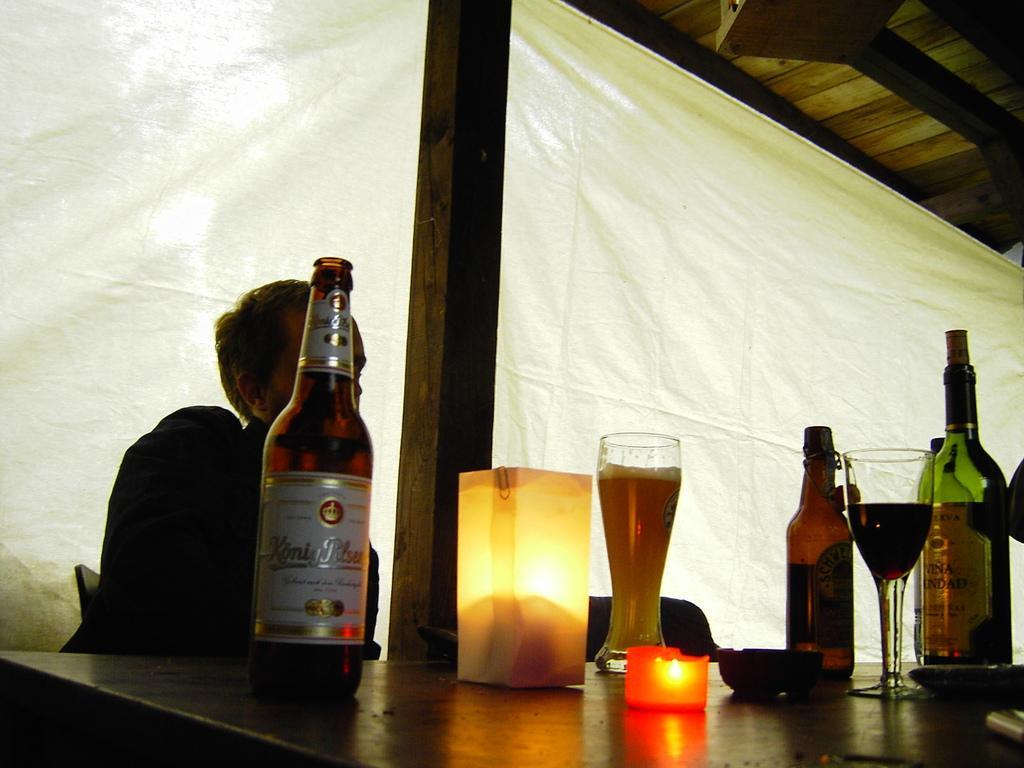Describe this image in one or two sentences. The person is sitting in a chair and there is a table in front of them which has wine bottles and a glass of wine in it and the background curtain is white in color. 